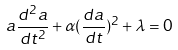<formula> <loc_0><loc_0><loc_500><loc_500>a \frac { d ^ { 2 } a } { d t ^ { 2 } } + \alpha ( \frac { d a } { d t } ) ^ { 2 } + \lambda = 0</formula> 